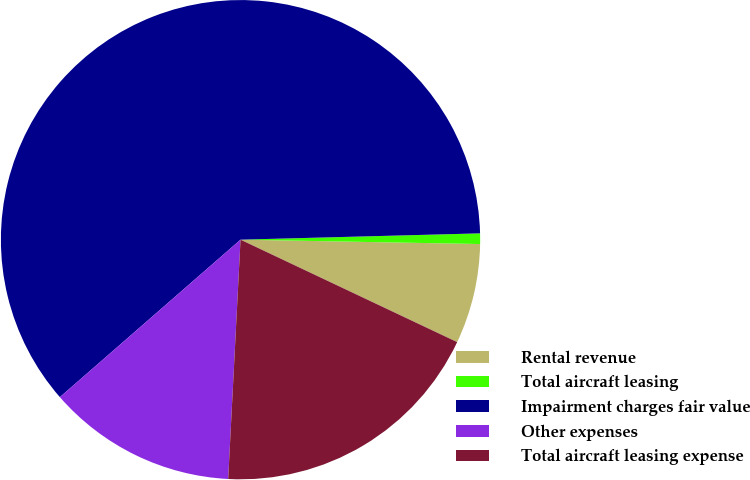<chart> <loc_0><loc_0><loc_500><loc_500><pie_chart><fcel>Rental revenue<fcel>Total aircraft leasing<fcel>Impairment charges fair value<fcel>Other expenses<fcel>Total aircraft leasing expense<nl><fcel>6.74%<fcel>0.71%<fcel>60.99%<fcel>12.77%<fcel>18.79%<nl></chart> 